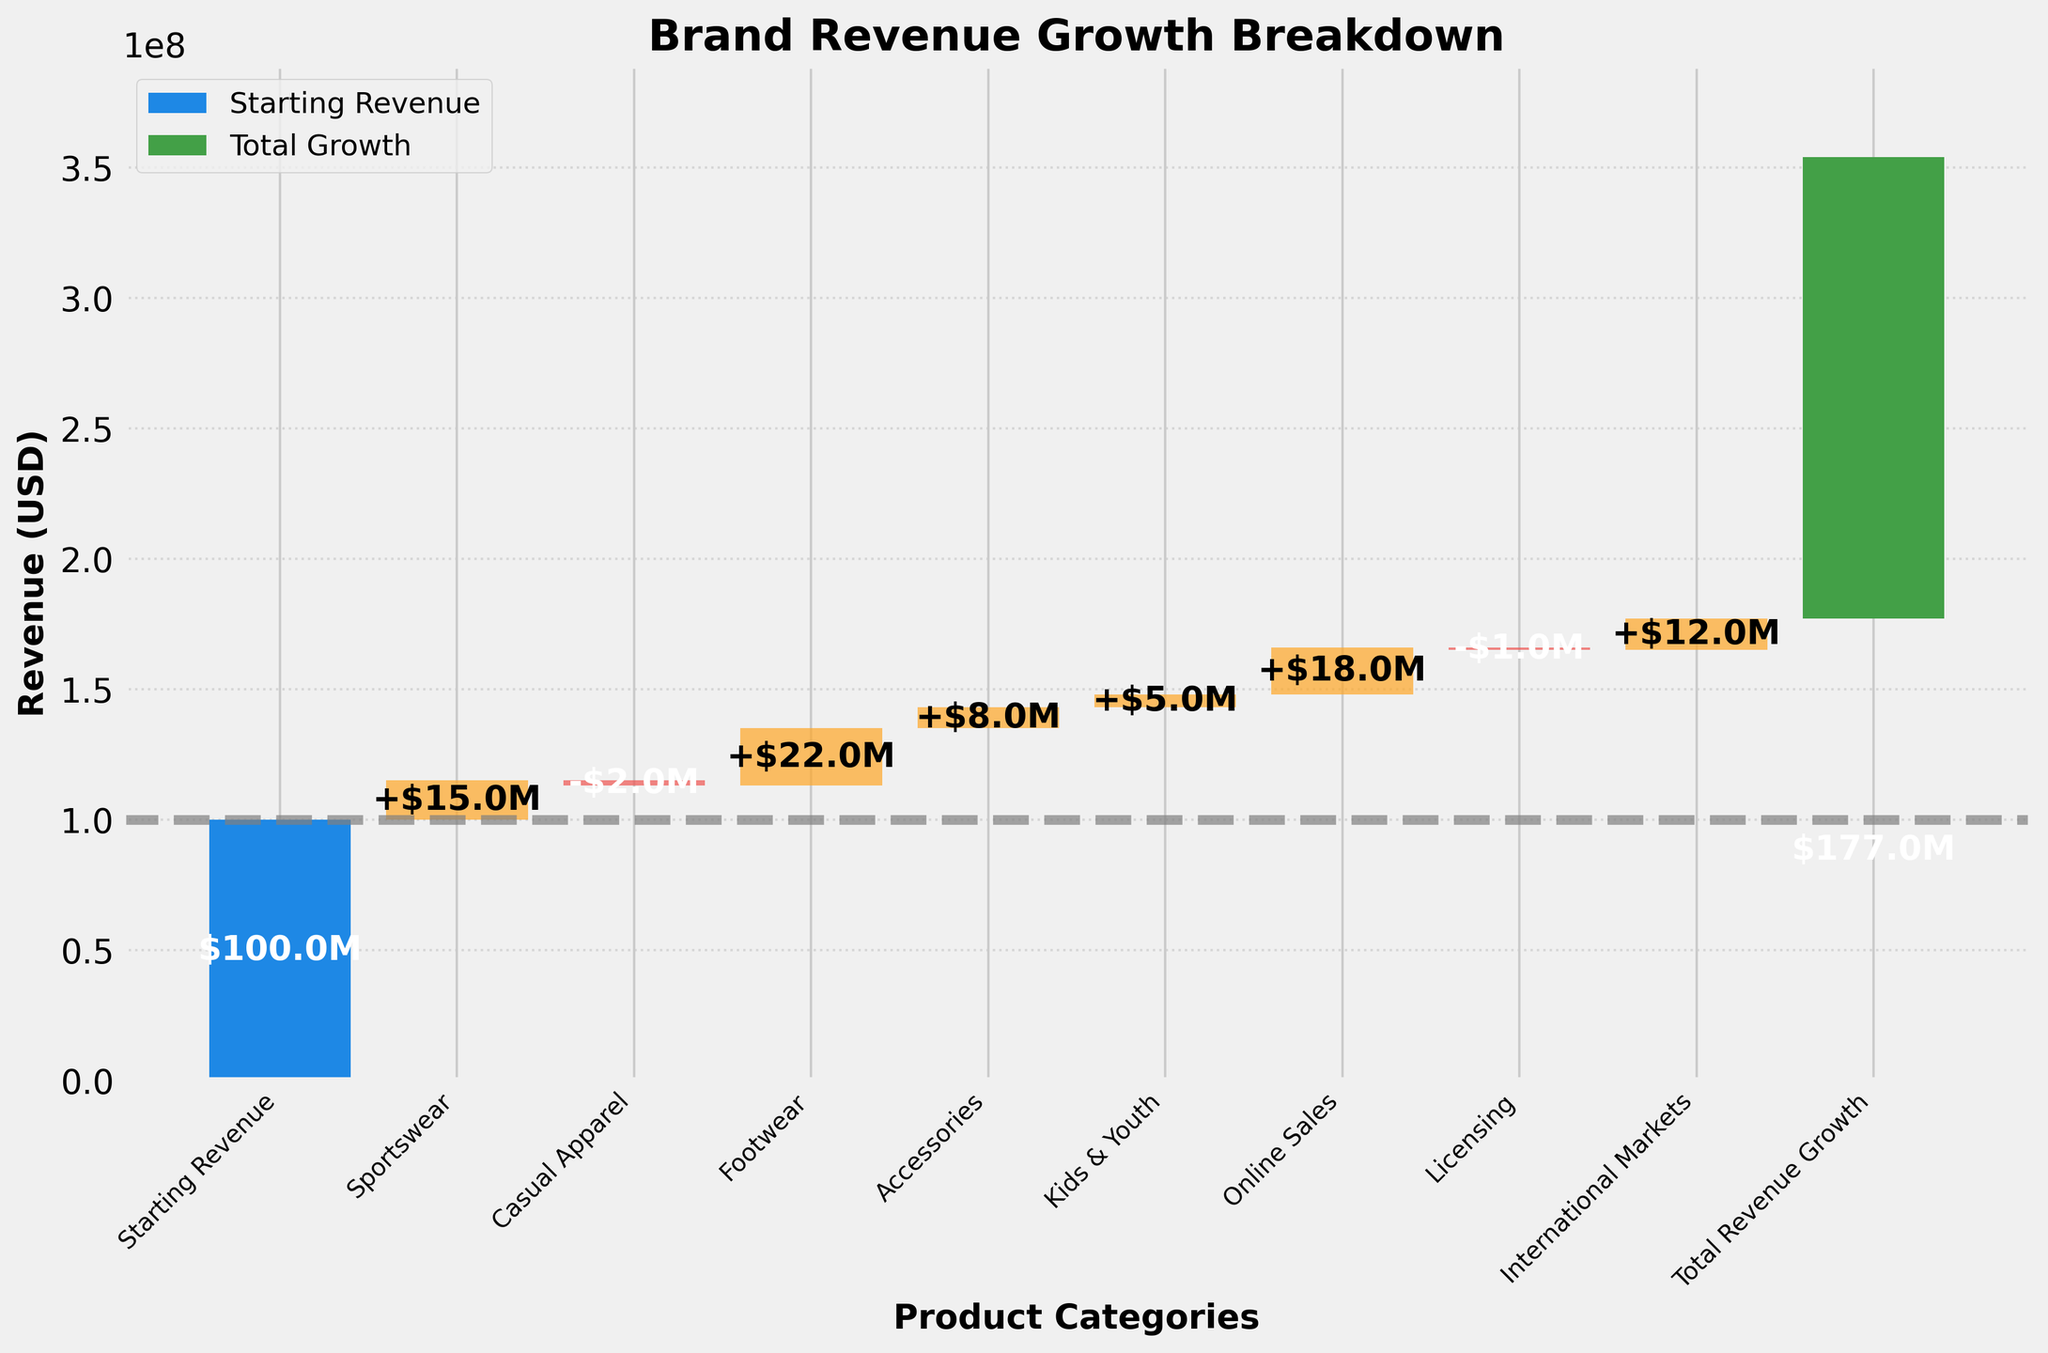What is the title of the chart? The title is located at the top of the chart.
Answer: Brand Revenue Growth Breakdown How many total product categories are displayed in the chart? To find the total, count the number of categories on the x-axis.
Answer: 10 Which product category contributed the most to revenue growth? Identify the category with the tallest bar above the x-axis.
Answer: Footwear What is the value for Casual Apparel? Locate the bar for Casual Apparel and read its value.
Answer: -$2M What is the cumulative revenue after Online Sales? Add the values of all categories up to and including Online Sales.
Answer: $158M How much did Accessories contribute to revenue growth? Find the bar labeled Accessories and read its value.
Answer: $8M Which product categories had a negative impact on revenue? Identify bars below the x-axis.
Answer: Casual Apparel, Licensing What is the total revenue growth across all product categories? Look at the final bar labeled 'Total Revenue Growth.'
Answer: $177M Compare the revenue impact of Sportswear and Kids & Youth. Which one contributed more? Compare the heights of the bars for Sportswear and Kids & Youth.
Answer: Sportswear What is the cumulative revenue after accounting for casual apparel's decrease? Sum Starting Revenue, Sportswear, then subtract Casual Apparel's impact.
Answer: $113M 